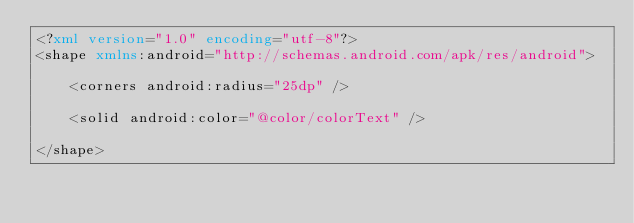Convert code to text. <code><loc_0><loc_0><loc_500><loc_500><_XML_><?xml version="1.0" encoding="utf-8"?>
<shape xmlns:android="http://schemas.android.com/apk/res/android">

    <corners android:radius="25dp" />

    <solid android:color="@color/colorText" />

</shape></code> 